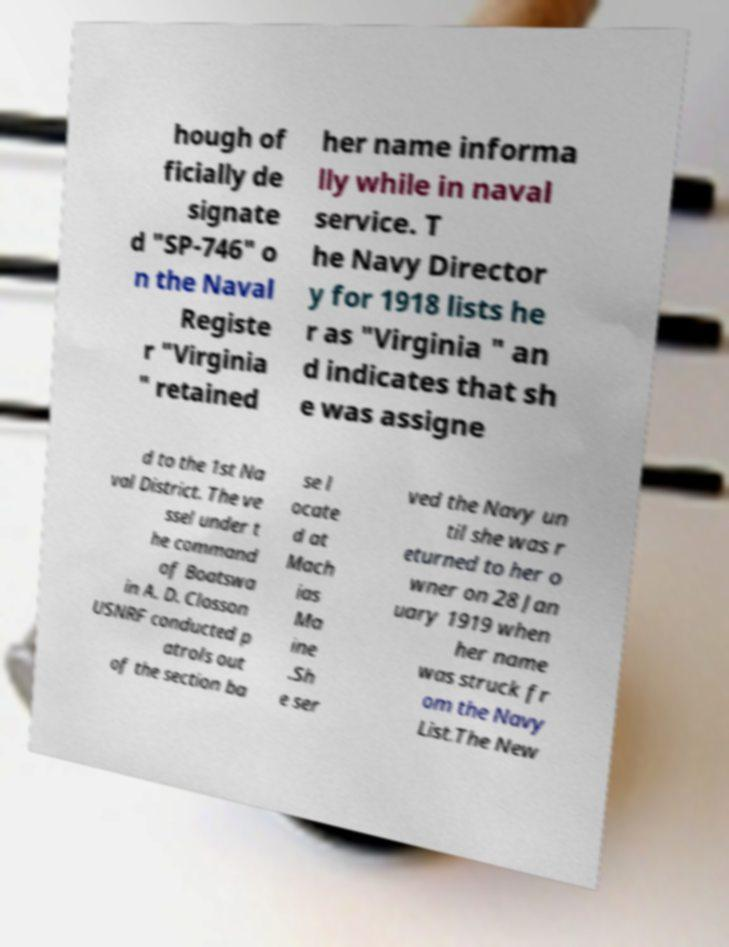Can you accurately transcribe the text from the provided image for me? hough of ficially de signate d "SP-746" o n the Naval Registe r "Virginia " retained her name informa lly while in naval service. T he Navy Director y for 1918 lists he r as "Virginia " an d indicates that sh e was assigne d to the 1st Na val District. The ve ssel under t he command of Boatswa in A. D. Closson USNRF conducted p atrols out of the section ba se l ocate d at Mach ias Ma ine .Sh e ser ved the Navy un til she was r eturned to her o wner on 28 Jan uary 1919 when her name was struck fr om the Navy List.The New 